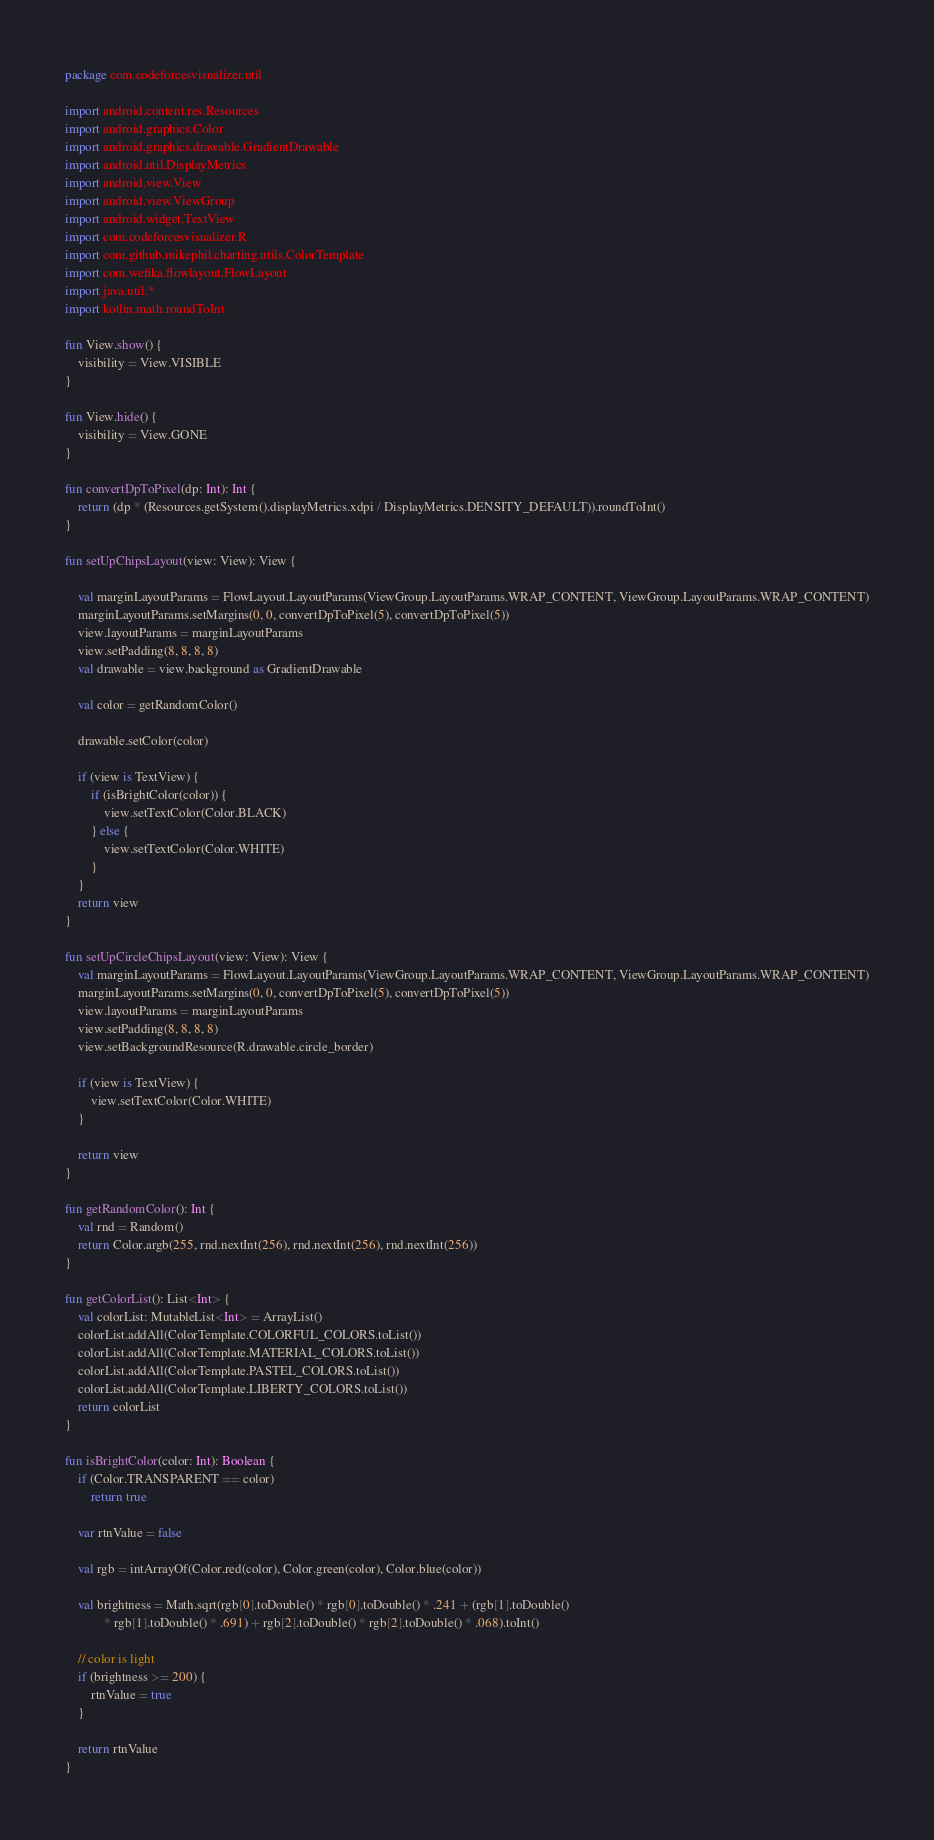<code> <loc_0><loc_0><loc_500><loc_500><_Kotlin_>package com.codeforcesvisualizer.util

import android.content.res.Resources
import android.graphics.Color
import android.graphics.drawable.GradientDrawable
import android.util.DisplayMetrics
import android.view.View
import android.view.ViewGroup
import android.widget.TextView
import com.codeforcesvisualizer.R
import com.github.mikephil.charting.utils.ColorTemplate
import com.wefika.flowlayout.FlowLayout
import java.util.*
import kotlin.math.roundToInt

fun View.show() {
    visibility = View.VISIBLE
}

fun View.hide() {
    visibility = View.GONE
}

fun convertDpToPixel(dp: Int): Int {
    return (dp * (Resources.getSystem().displayMetrics.xdpi / DisplayMetrics.DENSITY_DEFAULT)).roundToInt()
}

fun setUpChipsLayout(view: View): View {

    val marginLayoutParams = FlowLayout.LayoutParams(ViewGroup.LayoutParams.WRAP_CONTENT, ViewGroup.LayoutParams.WRAP_CONTENT)
    marginLayoutParams.setMargins(0, 0, convertDpToPixel(5), convertDpToPixel(5))
    view.layoutParams = marginLayoutParams
    view.setPadding(8, 8, 8, 8)
    val drawable = view.background as GradientDrawable

    val color = getRandomColor()

    drawable.setColor(color)

    if (view is TextView) {
        if (isBrightColor(color)) {
            view.setTextColor(Color.BLACK)
        } else {
            view.setTextColor(Color.WHITE)
        }
    }
    return view
}

fun setUpCircleChipsLayout(view: View): View {
    val marginLayoutParams = FlowLayout.LayoutParams(ViewGroup.LayoutParams.WRAP_CONTENT, ViewGroup.LayoutParams.WRAP_CONTENT)
    marginLayoutParams.setMargins(0, 0, convertDpToPixel(5), convertDpToPixel(5))
    view.layoutParams = marginLayoutParams
    view.setPadding(8, 8, 8, 8)
    view.setBackgroundResource(R.drawable.circle_border)

    if (view is TextView) {
        view.setTextColor(Color.WHITE)
    }

    return view
}

fun getRandomColor(): Int {
    val rnd = Random()
    return Color.argb(255, rnd.nextInt(256), rnd.nextInt(256), rnd.nextInt(256))
}

fun getColorList(): List<Int> {
    val colorList: MutableList<Int> = ArrayList()
    colorList.addAll(ColorTemplate.COLORFUL_COLORS.toList())
    colorList.addAll(ColorTemplate.MATERIAL_COLORS.toList())
    colorList.addAll(ColorTemplate.PASTEL_COLORS.toList())
    colorList.addAll(ColorTemplate.LIBERTY_COLORS.toList())
    return colorList
}

fun isBrightColor(color: Int): Boolean {
    if (Color.TRANSPARENT == color)
        return true

    var rtnValue = false

    val rgb = intArrayOf(Color.red(color), Color.green(color), Color.blue(color))

    val brightness = Math.sqrt(rgb[0].toDouble() * rgb[0].toDouble() * .241 + (rgb[1].toDouble()
            * rgb[1].toDouble() * .691) + rgb[2].toDouble() * rgb[2].toDouble() * .068).toInt()

    // color is light
    if (brightness >= 200) {
        rtnValue = true
    }

    return rtnValue
}</code> 